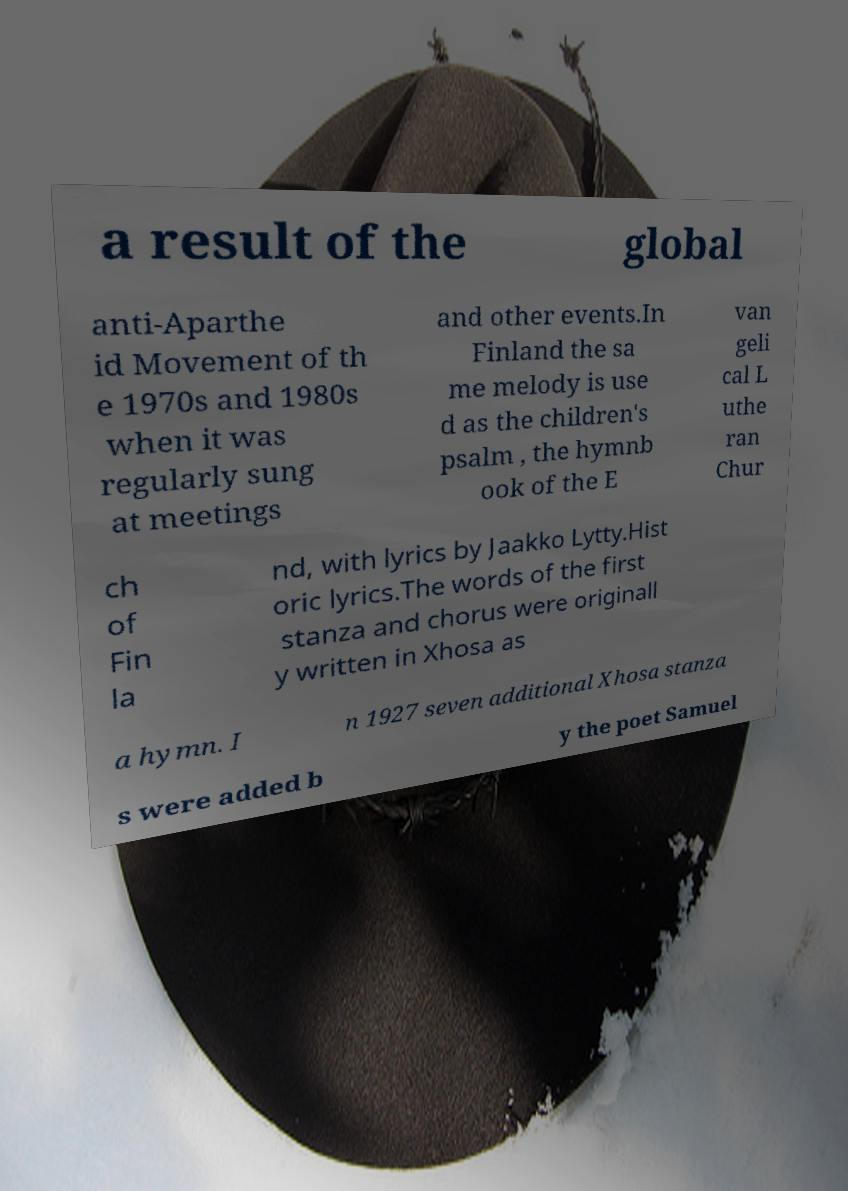What messages or text are displayed in this image? I need them in a readable, typed format. a result of the global anti-Aparthe id Movement of th e 1970s and 1980s when it was regularly sung at meetings and other events.In Finland the sa me melody is use d as the children's psalm , the hymnb ook of the E van geli cal L uthe ran Chur ch of Fin la nd, with lyrics by Jaakko Lytty.Hist oric lyrics.The words of the first stanza and chorus were originall y written in Xhosa as a hymn. I n 1927 seven additional Xhosa stanza s were added b y the poet Samuel 